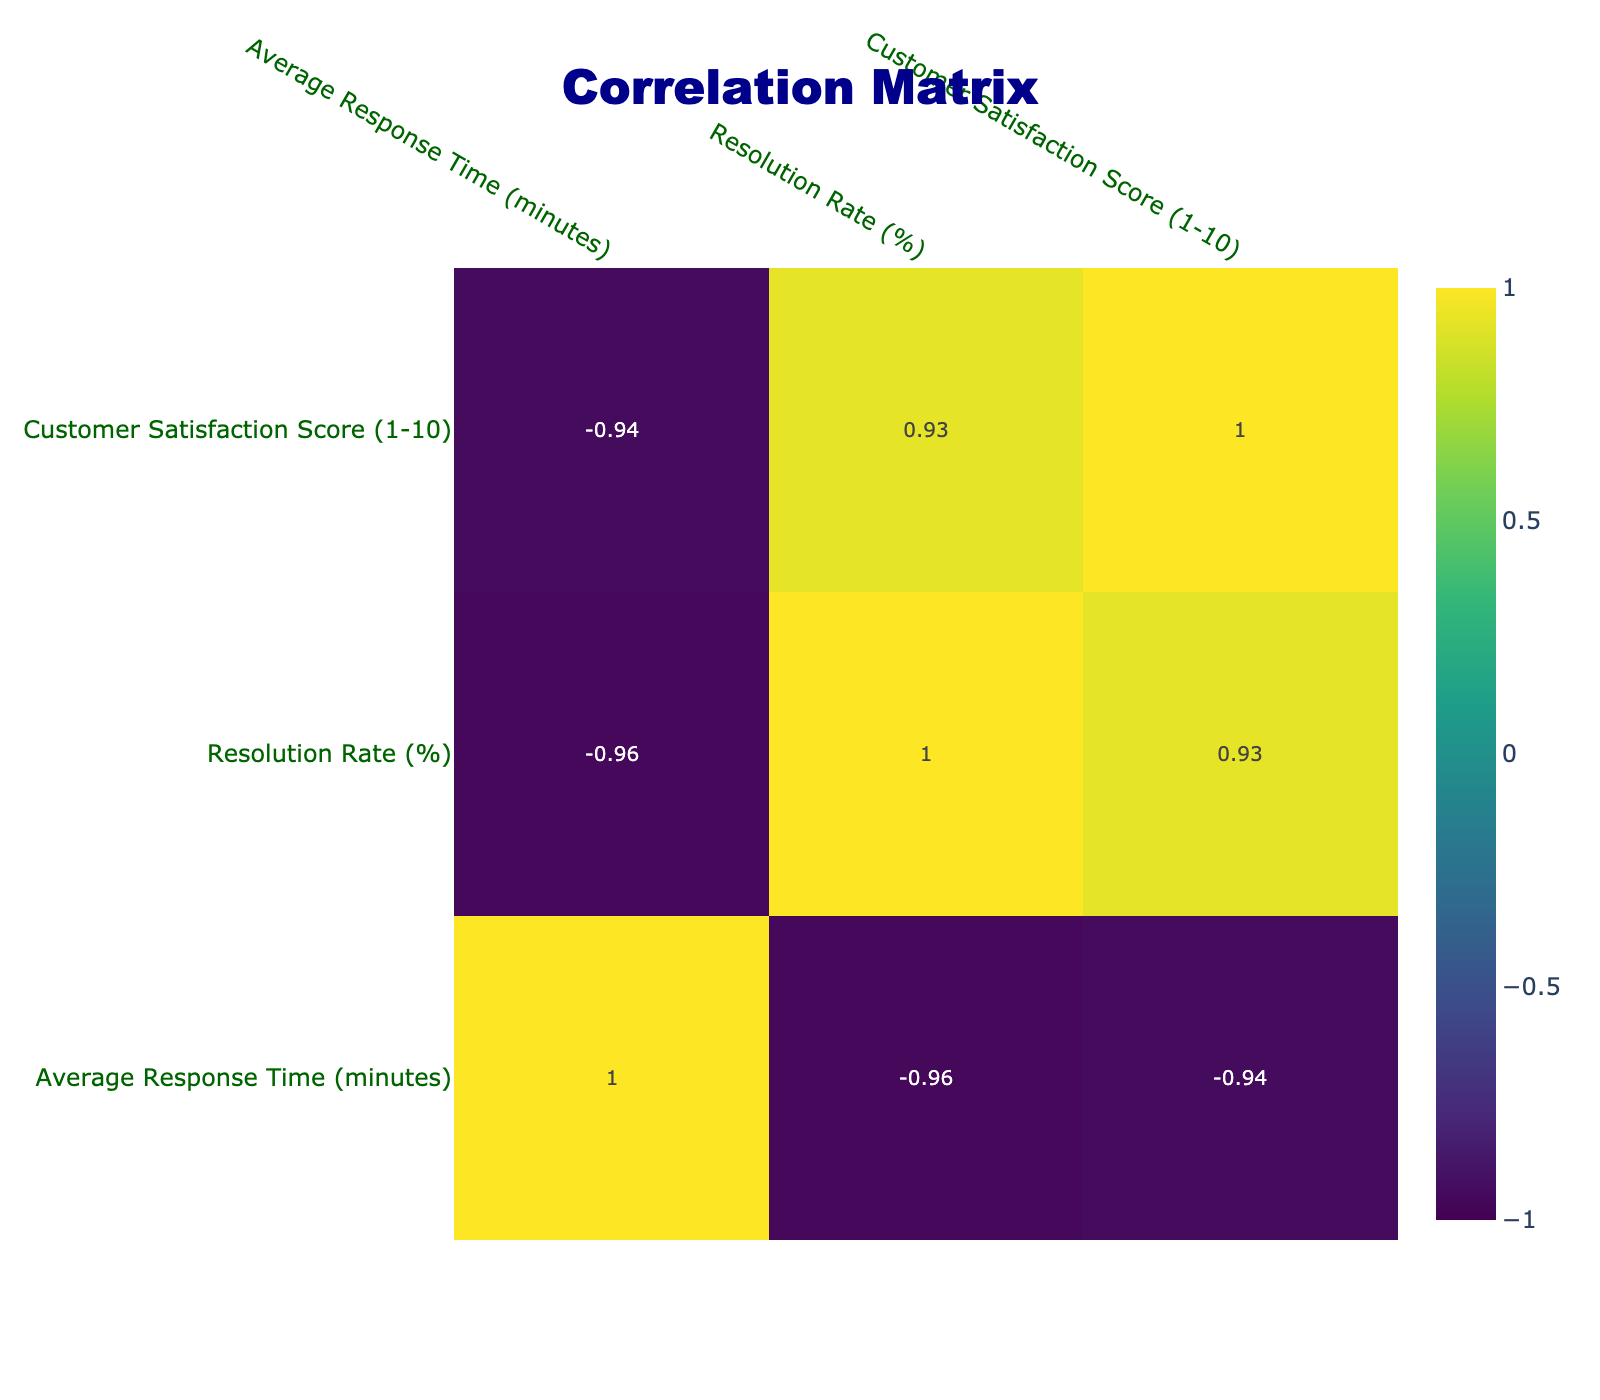What is the average response time in the Technology industry? The Technology industry has an average response time of 5.2 minutes listed in the table.
Answer: 5.2 minutes Which industry has the highest resolution rate? By inspecting the resolution rates of all industries in the table, the Food Service industry has the highest rate at 92%.
Answer: Food Service Is the average customer satisfaction score in Healthcare higher than in Insurance? The customer satisfaction score for Healthcare is 7.5, while for Insurance it is 6.9. Since 7.5 is greater than 6.9, the statement is true.
Answer: Yes What is the difference in average response time between Retail and Banking? The average response time for Retail is 4.7 minutes and for Banking it is 9.0 minutes. The difference is 9.0 - 4.7 = 4.3 minutes.
Answer: 4.3 minutes Which industry has an average satisfaction score below 8? By checking the customer satisfaction scores, Education with a score of 7.2 and Insurance with a score of 6.9 both have scores below 8.
Answer: Education and Insurance What is the median resolution rate across all industries? To find the median resolution rate: first, we list all rates: 85, 76, 90, 82, 78, 88, 73, 69, 81, 92. Sorting them gives (69, 73, 76, 78, 81, 82, 85, 88, 90, 92). With 10 data points, the median is the average of the 5th and 6th: (81 + 82) / 2 = 81.5.
Answer: 81.5% Is the average response time inversely correlated with the resolution rate? To check for inverse correlation, we examine values: as the average response time increases, the resolution rate tends to decrease (e.g., higher time in Insurance correlates with lower resolution). This suggests negative correlation.
Answer: Yes What is the total of average response times for industries with a satisfaction score above 8? Industries with a satisfaction score above 8 are Technology (5.2), Retail (4.7), Travel (6.8), and Food Service (3.5). The total is 5.2 + 4.7 + 6.8 + 3.5 = 20.2 minutes.
Answer: 20.2 minutes Which industry contrasts with the others in having both a lower resolution rate and a higher average response time? Healthcare and Insurance have lower resolution rates (76% and 69% respectively) and higher response times compared to other industries, making them contrasting.
Answer: Healthcare and Insurance 